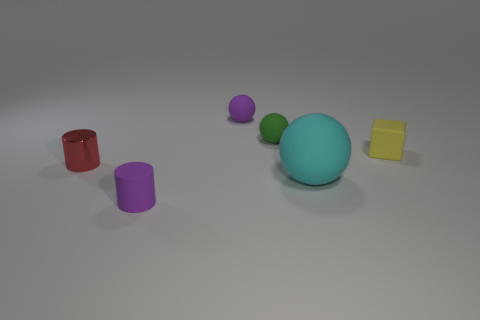Subtract all cyan spheres. How many spheres are left? 2 Subtract all purple cylinders. How many cylinders are left? 1 Subtract all blocks. How many objects are left? 5 Add 5 matte blocks. How many matte blocks are left? 6 Add 2 purple matte balls. How many purple matte balls exist? 3 Add 2 cyan objects. How many objects exist? 8 Subtract 0 blue cylinders. How many objects are left? 6 Subtract 1 balls. How many balls are left? 2 Subtract all brown blocks. Subtract all brown cylinders. How many blocks are left? 1 Subtract all brown cylinders. How many green spheres are left? 1 